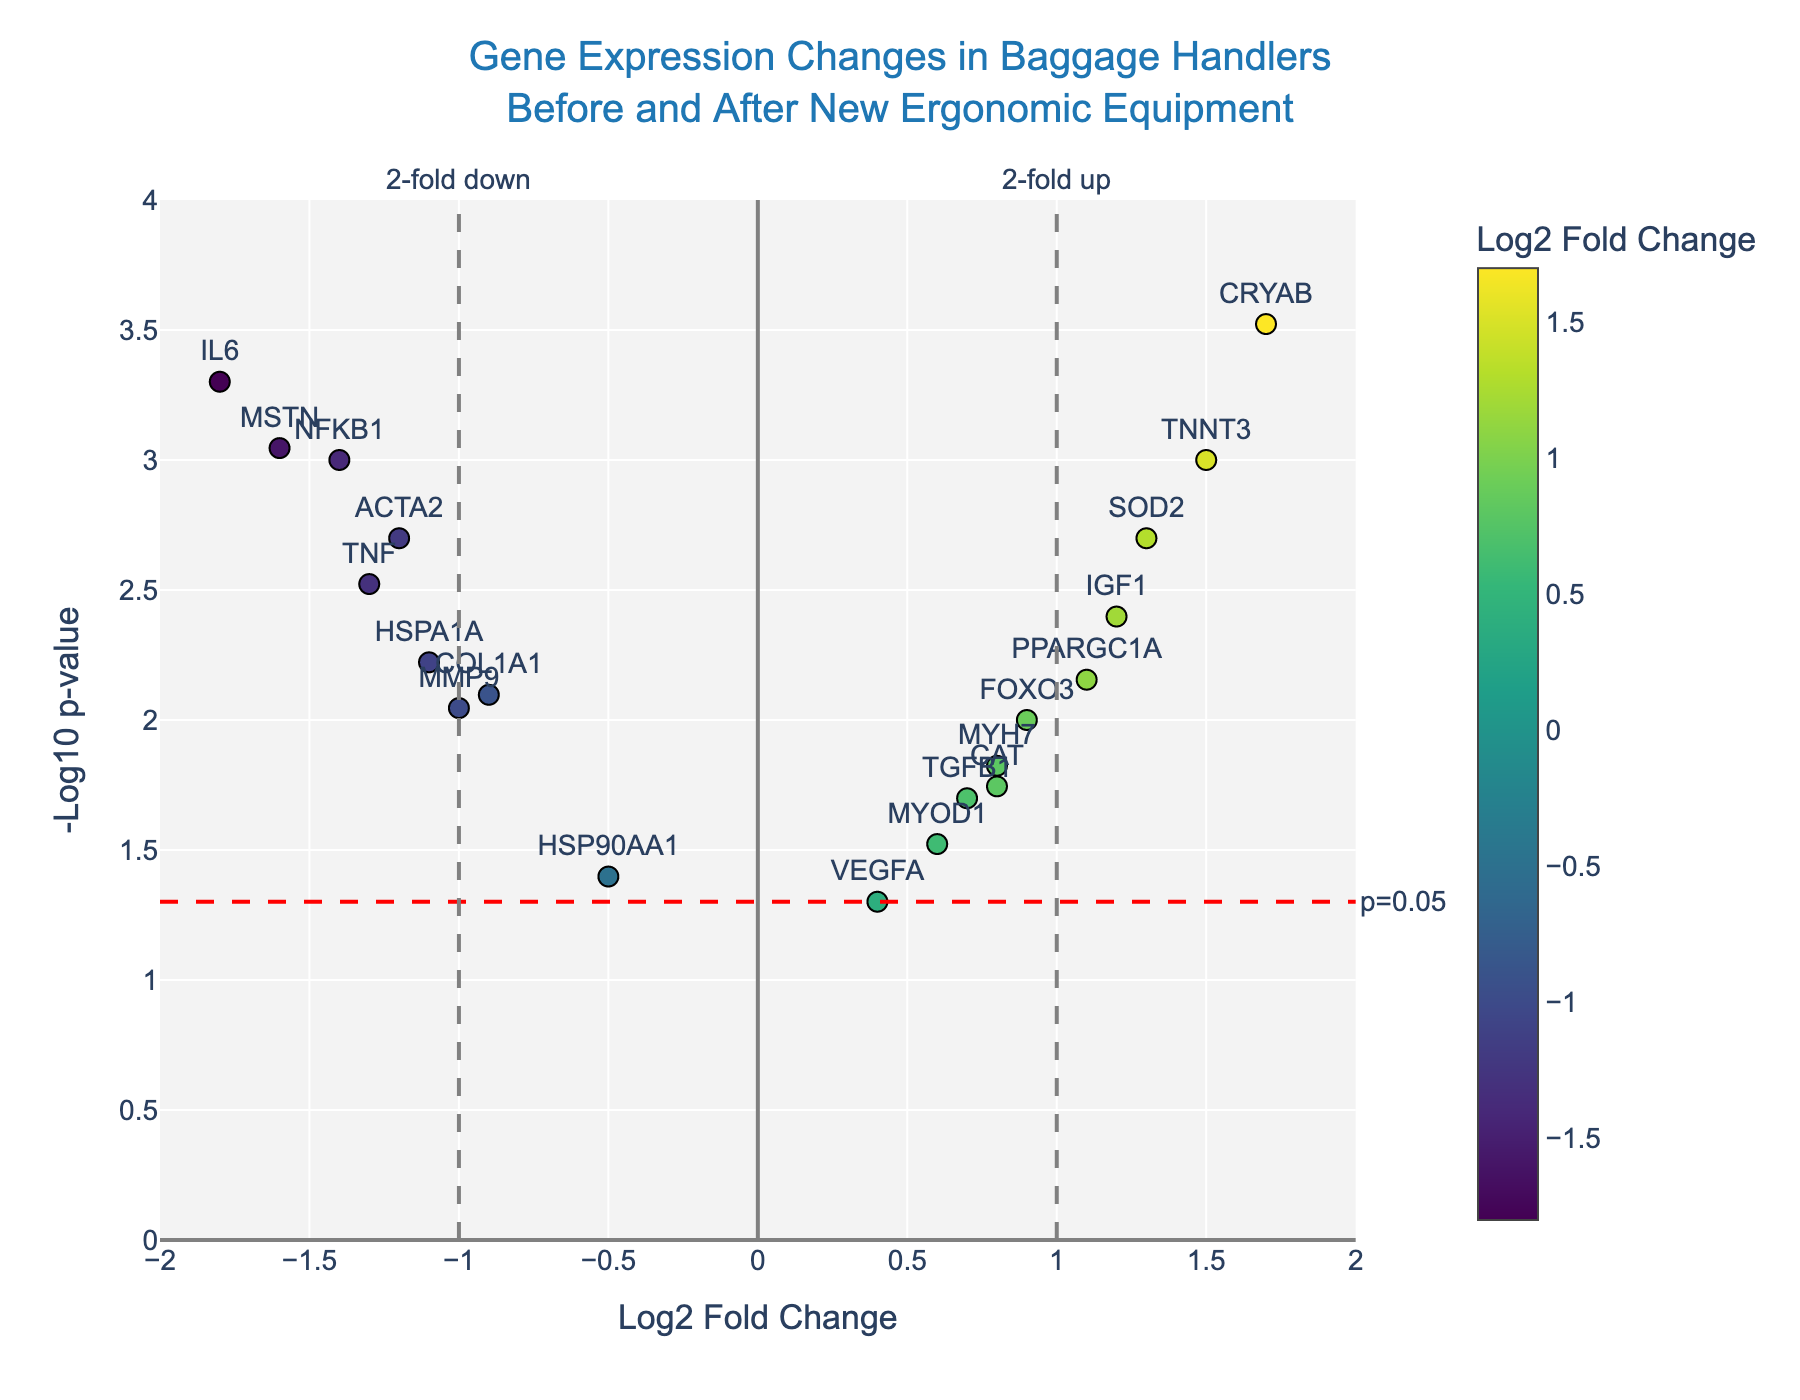Which gene has the highest -log10 p-value? The gene with the highest -log10 p-value corresponds to the point positioned highest on the y-axis. From the plot, the gene "CRYAB" has the highest -log10 p-value.
Answer: CRYAB How many genes are significantly upregulated with at least 2-fold change? Significantly upregulated genes with at least 2-fold change are those with log2 fold change ≥ 1 and a p-value < 0.05 (above the red dashed line). From the plot, the genes "TNNT3," "IGF1," and "PPARGC1A" meet these criteria.
Answer: 3 Which gene has the largest negative log2 fold change? The largest negative log2 fold change corresponds to the point furthest to the left on the x-axis. From the plot, "IL6" has the largest negative log2 fold change at -1.8.
Answer: IL6 Are there any genes with a p-value exactly at 0.05? The red dashed line represents a p-value threshold of 0.05. None of the genes fall exactly on this threshold line; they are either above or below it.
Answer: No Which genes are both significantly downregulated and have at least a 2-fold change? Significantly downregulated genes with at least 2-fold change have a log2 fold change ≤ -1 and a p-value < 0.05. From the plot, the genes "IL6," "MSTN," "NFKB1," "HSPA1A," "TNF," and "ACTA2" meet these criteria.
Answer: 6 What is the title of the figure? The title is located at the top center of the figure. It states, "Gene Expression Changes in Baggage Handlers Before and After New Ergonomic Equipment."
Answer: Gene Expression Changes in Baggage Handlers Before and After New Ergonomic Equipment How many genes fall above the significance threshold of -log10(p-value) = 1.3? The significance threshold of -log10(p-value) = 1.3 corresponds to a p-value of 0.05. Counting the points above this line will give the answer. From the plot, there are 17 genes above the threshold.
Answer: 17 Which genes have a positive log2 fold change and are significant at p-value < 0.01? These genes are positioned to the right of the vertical line x=0 and above the red dashed horizontal line. The relevant genes are "TNNT3," "IGF1," "PPARGC1A," and "SOD2."
Answer: 4 Is there any gene with a log2 fold change greater than 1.5? From the plot, the gene "CRYAB" is positioned furthest to the right with a value greater than 1.5, specifically at 1.7.
Answer: Yes 